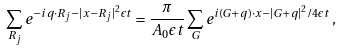<formula> <loc_0><loc_0><loc_500><loc_500>\sum _ { { R } _ { j } } e ^ { - i { q } \cdot { R } _ { j } - | { x } - { R } _ { j } | ^ { 2 } \epsilon t } = \frac { \pi } { A _ { 0 } \epsilon t } \sum _ { G } e ^ { i ( { G } + { q } ) \cdot { x } - { | { G } + { q } | ^ { 2 } } / { 4 \epsilon t } } \, ,</formula> 